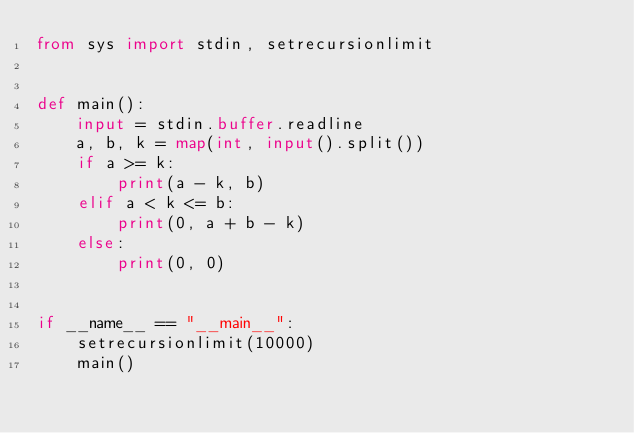Convert code to text. <code><loc_0><loc_0><loc_500><loc_500><_Python_>from sys import stdin, setrecursionlimit


def main():
    input = stdin.buffer.readline
    a, b, k = map(int, input().split())
    if a >= k:
        print(a - k, b)
    elif a < k <= b:
        print(0, a + b - k)
    else:
        print(0, 0)


if __name__ == "__main__":
    setrecursionlimit(10000)
    main()
</code> 